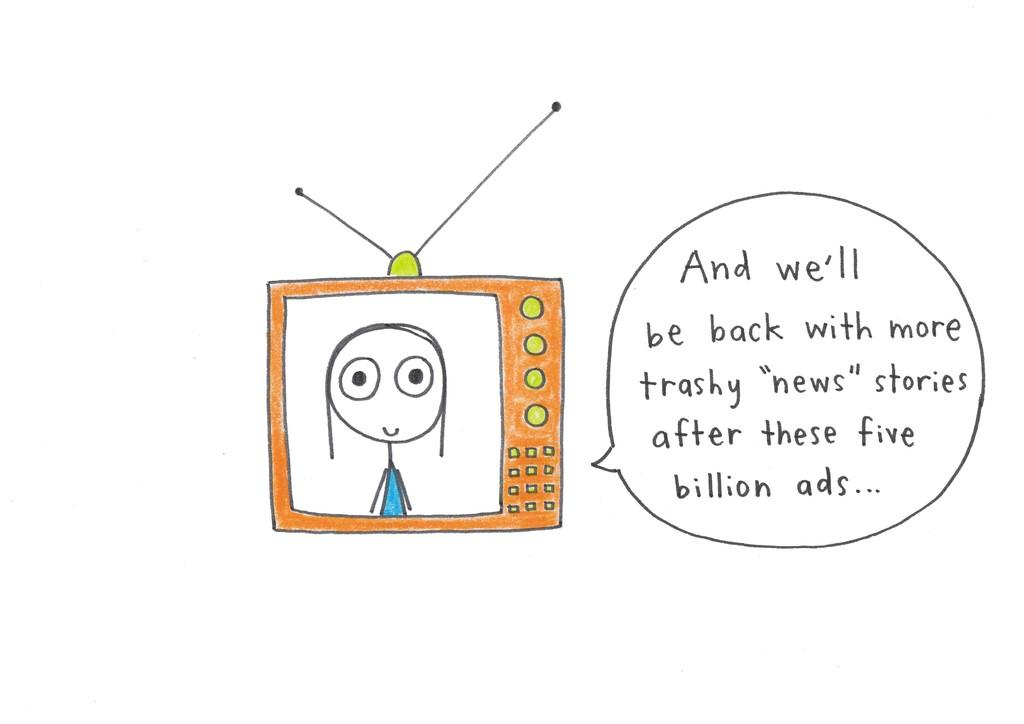What electronic device is present in the image? There is a television in the image. What is related to the television in the image? There is art related to the television in the image. How is the text in the image modified? The text in the comment in the image is edited. What color is the background of the image? The background of the image is white. What type of nerve can be seen in the image? There is no nerve present in the image; it features a television and related art. 